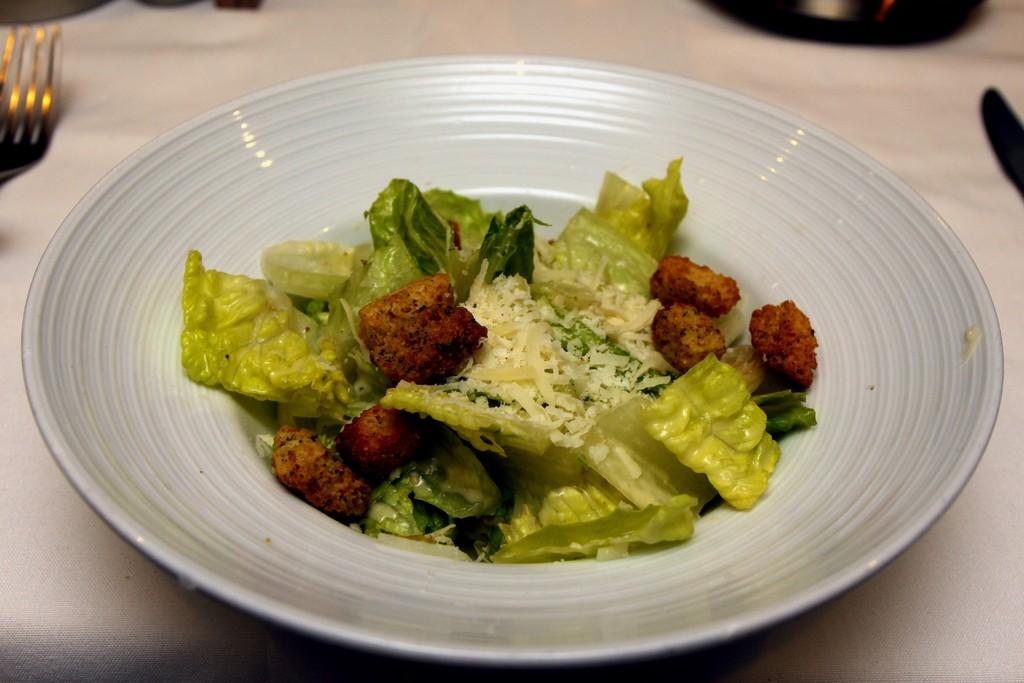What is on the plate in the foreground of the image? There is a plate containing food in the foreground of the image. On what surface is the plate placed? The plate is placed on a surface. What utensils can be seen in the background of the image? There are spoons in the background of the image. What else is visible in the background of the image? There is a bowl in the background of the image. What type of string is used to tie the nest in the image? There is no nest present in the image, so it is not possible to determine what type of string might be used to tie it. 